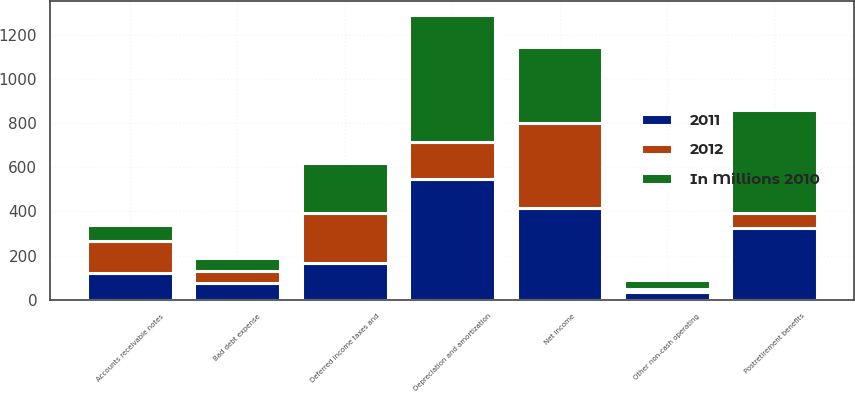<chart> <loc_0><loc_0><loc_500><loc_500><stacked_bar_chart><ecel><fcel>Net income<fcel>Depreciation and amortization<fcel>Deferred income taxes and<fcel>Postretirement benefits<fcel>Bad debt expense<fcel>Other non-cash operating<fcel>Accounts receivable notes<nl><fcel>2012<fcel>384<fcel>167<fcel>227<fcel>72<fcel>57<fcel>16<fcel>147<nl><fcel>2011<fcel>417<fcel>546<fcel>167<fcel>323<fcel>74<fcel>33<fcel>119<nl><fcel>In Millions 2010<fcel>343<fcel>576<fcel>227<fcel>463<fcel>57<fcel>39<fcel>72<nl></chart> 